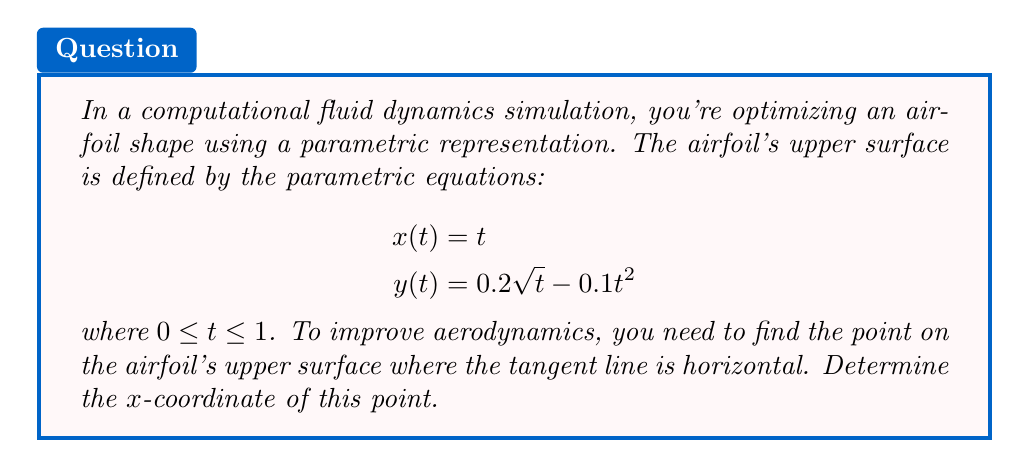Can you solve this math problem? To solve this problem, we'll follow these steps:

1) The tangent line is horizontal when the derivative $\frac{dy}{dx} = 0$. In parametric form, this occurs when $\frac{dy}{dt} = 0$, assuming $\frac{dx}{dt} \neq 0$.

2) Let's find $\frac{dy}{dt}$:
   $$\frac{dy}{dt} = \frac{d}{dt}(0.2\sqrt{t} - 0.1t^2) = \frac{0.1}{\sqrt{t}} - 0.2t$$

3) Set this equal to zero and solve for $t$:
   $$\frac{0.1}{\sqrt{t}} - 0.2t = 0$$
   $$0.1 = 0.2t\sqrt{t} = 0.2t^{3/2}$$
   $$0.5 = t^{3/2}$$
   $$t = (\frac{1}{2})^{2/3} = \frac{1}{2^{2/3}}$$

4) Now that we know the $t$ value, we can find the $x$-coordinate. Recall that $x(t) = t$, so:
   $$x = \frac{1}{2^{2/3}}$$

This is the $x$-coordinate of the point where the tangent line is horizontal on the upper surface of the airfoil.
Answer: $x = \frac{1}{2^{2/3}}$ or approximately 0.6300 